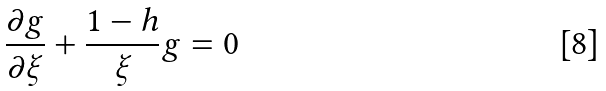Convert formula to latex. <formula><loc_0><loc_0><loc_500><loc_500>\frac { \partial g } { \partial \xi } + \frac { 1 - h } { \xi } g = 0</formula> 